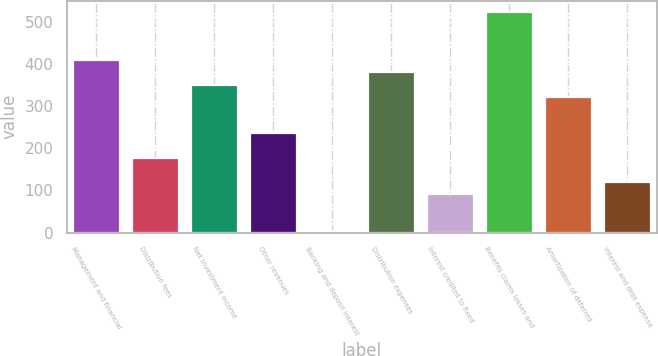Convert chart. <chart><loc_0><loc_0><loc_500><loc_500><bar_chart><fcel>Management and financial<fcel>Distribution fees<fcel>Net investment income<fcel>Other revenues<fcel>Banking and deposit interest<fcel>Distribution expenses<fcel>Interest credited to fixed<fcel>Benefits claims losses and<fcel>Amortization of deferred<fcel>Interest and debt expense<nl><fcel>408.2<fcel>177.8<fcel>350.6<fcel>235.4<fcel>5<fcel>379.4<fcel>91.4<fcel>523.4<fcel>321.8<fcel>120.2<nl></chart> 